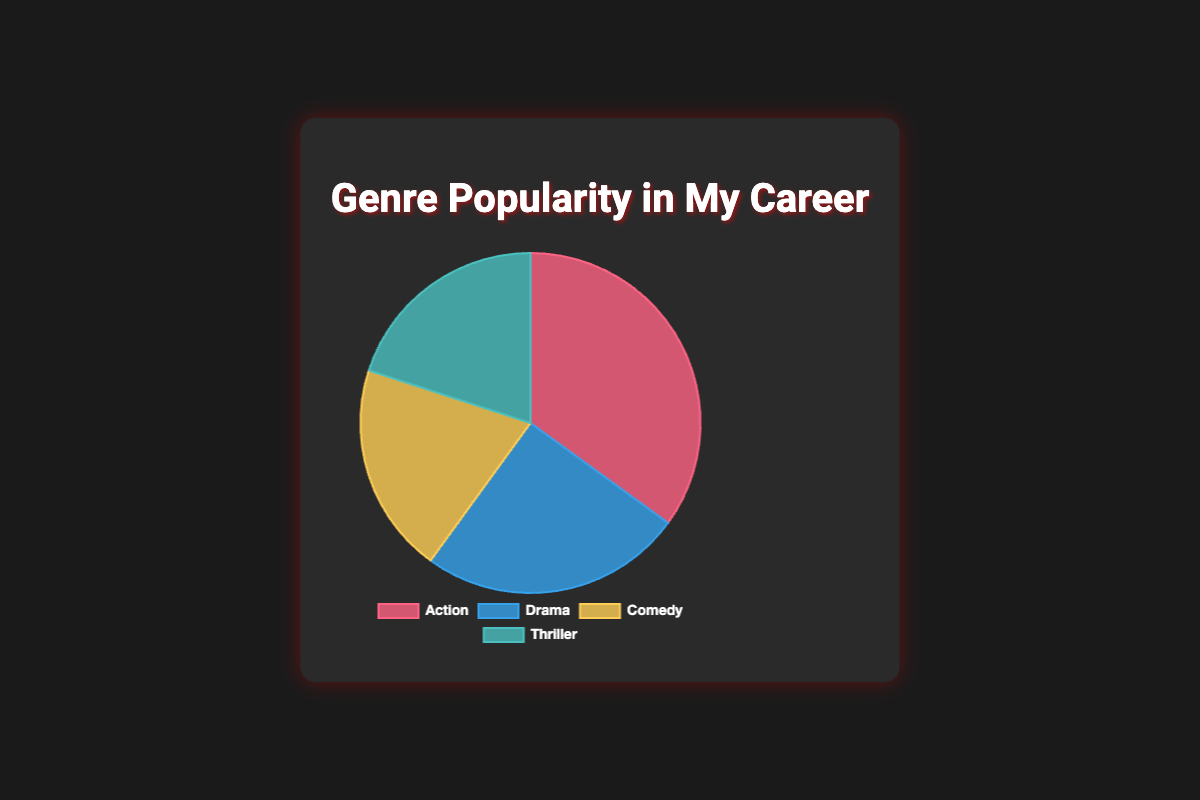What is the most popular genre? The most popular genre can be identified as the one with the highest percentage in the chart. Looking at the data, Action has the highest value of 35%.
Answer: Action Which genres are equally popular? The genres with equal percentages can be found by looking for segments with the same value in the chart. Comedy and Thriller both have 20%.
Answer: Comedy and Thriller What is the total popularity percentage of non-action genres? Sum the percentages of Drama, Comedy, and Thriller: 25% (Drama) + 20% (Comedy) + 20% (Thriller) = 65%.
Answer: 65% What is the difference in popularity between Action and Drama? The difference in popularity can be found by subtracting the Drama percentage from the Action percentage: 35% (Action) - 25% (Drama) = 10%.
Answer: 10% What fraction of the total does Comedy represent? To find the fraction, divide Comedy's percentage by the total: 20% (Comedy) / 100% = 0.20.
Answer: 0.20 Which genre is the least popular? By comparing the values, the genre with the smallest percentage is a tie between Comedy and Thriller, each having 20%.
Answer: Comedy and Thriller If you combine the popularity of Drama and Thriller, how does it compare to Action? Add the percentages of Drama and Thriller and compare it to Action's percentage. Drama (25%) + Thriller (20%) = 45%, which is greater than Action's 35%.
Answer: 45% > 35% What is the average popularity of the four genres? Sum the percentages and divide by the number of genres: (35% + 25% + 20% + 20%) / 4 = 100% / 4 = 25%.
Answer: 25% How much more popular is Action compared to Comedy? Subtract Comedy's percentage from Action's percentage: 35% (Action) - 20% (Comedy) = 15%.
Answer: 15% What color represents the Thriller genre in the chart? The Thriller genre is indicated by the segment colored in a turquoise-blue shade.
Answer: Turquoise-blue 